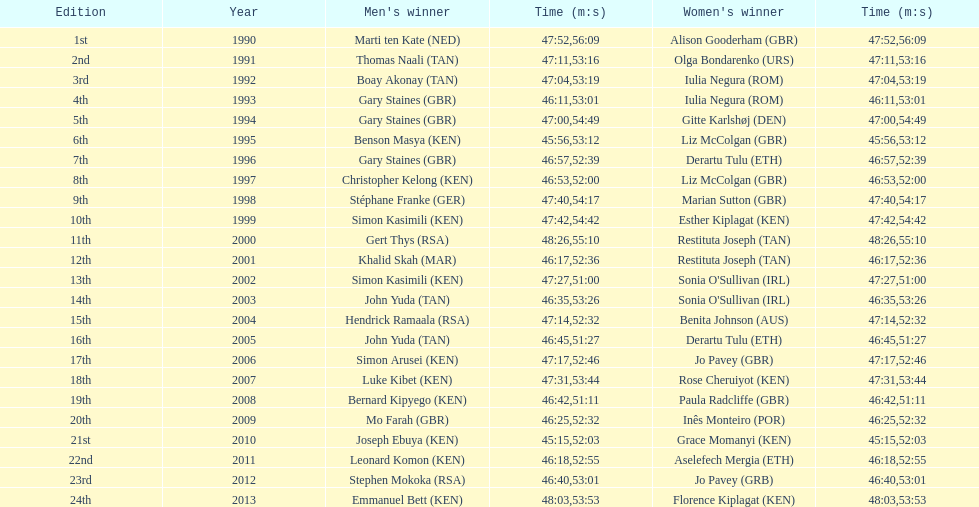Home many times did a single country win both the men's and women's bupa great south run? 4. Would you be able to parse every entry in this table? {'header': ['Edition', 'Year', "Men's winner", 'Time (m:s)', "Women's winner", 'Time (m:s)'], 'rows': [['1st', '1990', 'Marti ten Kate\xa0(NED)', '47:52', 'Alison Gooderham\xa0(GBR)', '56:09'], ['2nd', '1991', 'Thomas Naali\xa0(TAN)', '47:11', 'Olga Bondarenko\xa0(URS)', '53:16'], ['3rd', '1992', 'Boay Akonay\xa0(TAN)', '47:04', 'Iulia Negura\xa0(ROM)', '53:19'], ['4th', '1993', 'Gary Staines\xa0(GBR)', '46:11', 'Iulia Negura\xa0(ROM)', '53:01'], ['5th', '1994', 'Gary Staines\xa0(GBR)', '47:00', 'Gitte Karlshøj\xa0(DEN)', '54:49'], ['6th', '1995', 'Benson Masya\xa0(KEN)', '45:56', 'Liz McColgan\xa0(GBR)', '53:12'], ['7th', '1996', 'Gary Staines\xa0(GBR)', '46:57', 'Derartu Tulu\xa0(ETH)', '52:39'], ['8th', '1997', 'Christopher Kelong\xa0(KEN)', '46:53', 'Liz McColgan\xa0(GBR)', '52:00'], ['9th', '1998', 'Stéphane Franke\xa0(GER)', '47:40', 'Marian Sutton\xa0(GBR)', '54:17'], ['10th', '1999', 'Simon Kasimili\xa0(KEN)', '47:42', 'Esther Kiplagat\xa0(KEN)', '54:42'], ['11th', '2000', 'Gert Thys\xa0(RSA)', '48:26', 'Restituta Joseph\xa0(TAN)', '55:10'], ['12th', '2001', 'Khalid Skah\xa0(MAR)', '46:17', 'Restituta Joseph\xa0(TAN)', '52:36'], ['13th', '2002', 'Simon Kasimili\xa0(KEN)', '47:27', "Sonia O'Sullivan\xa0(IRL)", '51:00'], ['14th', '2003', 'John Yuda\xa0(TAN)', '46:35', "Sonia O'Sullivan\xa0(IRL)", '53:26'], ['15th', '2004', 'Hendrick Ramaala\xa0(RSA)', '47:14', 'Benita Johnson\xa0(AUS)', '52:32'], ['16th', '2005', 'John Yuda\xa0(TAN)', '46:45', 'Derartu Tulu\xa0(ETH)', '51:27'], ['17th', '2006', 'Simon Arusei\xa0(KEN)', '47:17', 'Jo Pavey\xa0(GBR)', '52:46'], ['18th', '2007', 'Luke Kibet\xa0(KEN)', '47:31', 'Rose Cheruiyot\xa0(KEN)', '53:44'], ['19th', '2008', 'Bernard Kipyego\xa0(KEN)', '46:42', 'Paula Radcliffe\xa0(GBR)', '51:11'], ['20th', '2009', 'Mo Farah\xa0(GBR)', '46:25', 'Inês Monteiro\xa0(POR)', '52:32'], ['21st', '2010', 'Joseph Ebuya\xa0(KEN)', '45:15', 'Grace Momanyi\xa0(KEN)', '52:03'], ['22nd', '2011', 'Leonard Komon\xa0(KEN)', '46:18', 'Aselefech Mergia\xa0(ETH)', '52:55'], ['23rd', '2012', 'Stephen Mokoka\xa0(RSA)', '46:40', 'Jo Pavey\xa0(GRB)', '53:01'], ['24th', '2013', 'Emmanuel Bett\xa0(KEN)', '48:03', 'Florence Kiplagat\xa0(KEN)', '53:53']]} 